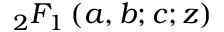Convert formula to latex. <formula><loc_0><loc_0><loc_500><loc_500>_ { 2 } F _ { 1 } \left ( a , b ; c ; z \right )</formula> 